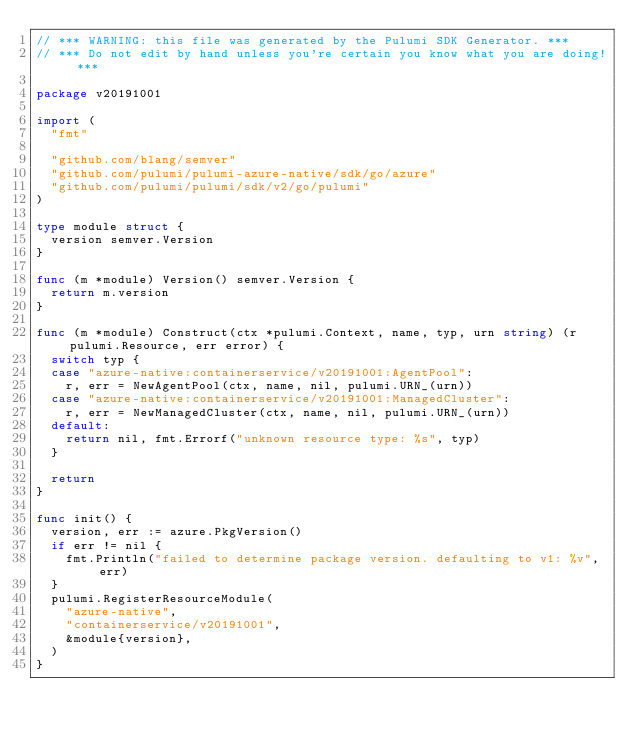Convert code to text. <code><loc_0><loc_0><loc_500><loc_500><_Go_>// *** WARNING: this file was generated by the Pulumi SDK Generator. ***
// *** Do not edit by hand unless you're certain you know what you are doing! ***

package v20191001

import (
	"fmt"

	"github.com/blang/semver"
	"github.com/pulumi/pulumi-azure-native/sdk/go/azure"
	"github.com/pulumi/pulumi/sdk/v2/go/pulumi"
)

type module struct {
	version semver.Version
}

func (m *module) Version() semver.Version {
	return m.version
}

func (m *module) Construct(ctx *pulumi.Context, name, typ, urn string) (r pulumi.Resource, err error) {
	switch typ {
	case "azure-native:containerservice/v20191001:AgentPool":
		r, err = NewAgentPool(ctx, name, nil, pulumi.URN_(urn))
	case "azure-native:containerservice/v20191001:ManagedCluster":
		r, err = NewManagedCluster(ctx, name, nil, pulumi.URN_(urn))
	default:
		return nil, fmt.Errorf("unknown resource type: %s", typ)
	}

	return
}

func init() {
	version, err := azure.PkgVersion()
	if err != nil {
		fmt.Println("failed to determine package version. defaulting to v1: %v", err)
	}
	pulumi.RegisterResourceModule(
		"azure-native",
		"containerservice/v20191001",
		&module{version},
	)
}
</code> 